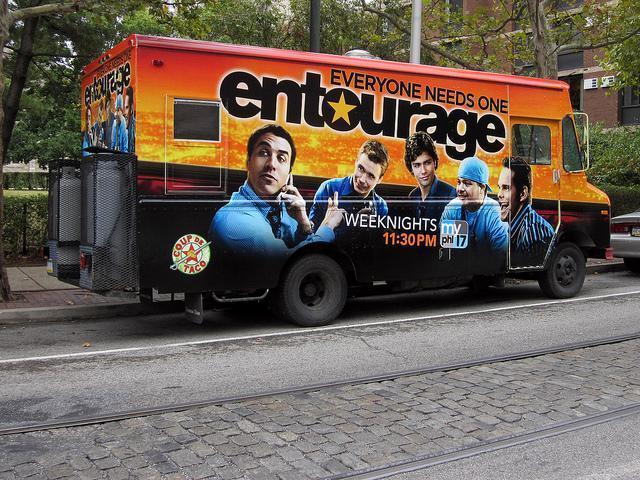Why does the van have a realistic photo on the side?
Select the correct answer and articulate reasoning with the following format: 'Answer: answer
Rationale: rationale.'
Options: By law, advertising, for fun, for aesthetics. Answer: advertising.
Rationale: The name of a television program with the time and network to watch it on is present on this truck. this truck is serving as an advertisement for the program. 